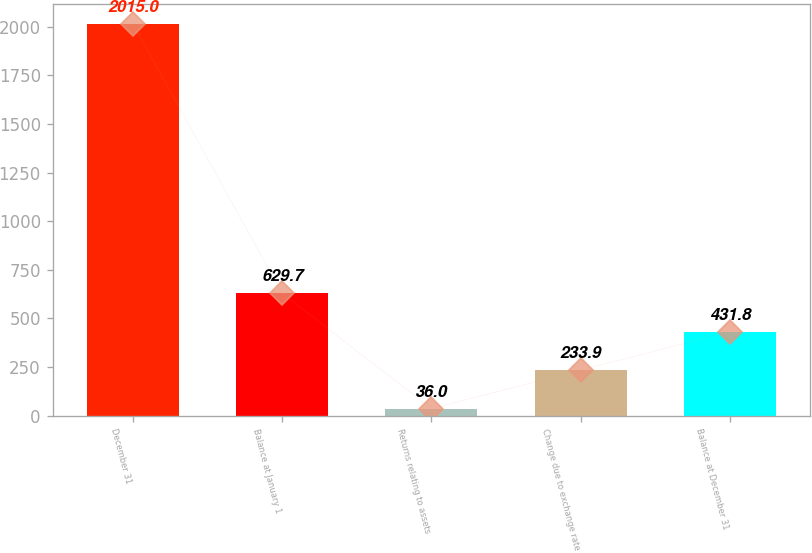Convert chart to OTSL. <chart><loc_0><loc_0><loc_500><loc_500><bar_chart><fcel>December 31<fcel>Balance at January 1<fcel>Returns relating to assets<fcel>Change due to exchange rate<fcel>Balance at December 31<nl><fcel>2015<fcel>629.7<fcel>36<fcel>233.9<fcel>431.8<nl></chart> 